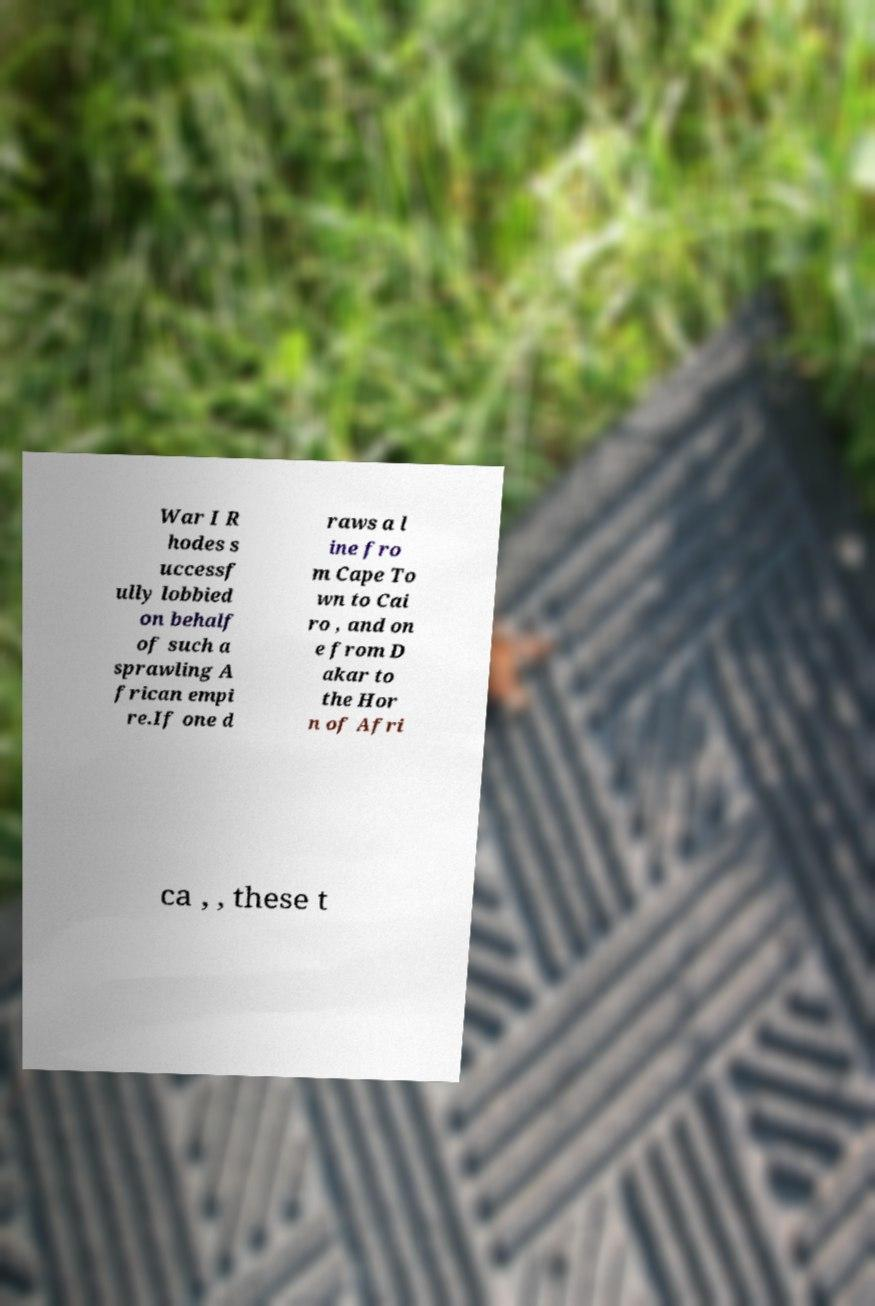Can you read and provide the text displayed in the image?This photo seems to have some interesting text. Can you extract and type it out for me? War I R hodes s uccessf ully lobbied on behalf of such a sprawling A frican empi re.If one d raws a l ine fro m Cape To wn to Cai ro , and on e from D akar to the Hor n of Afri ca , , these t 